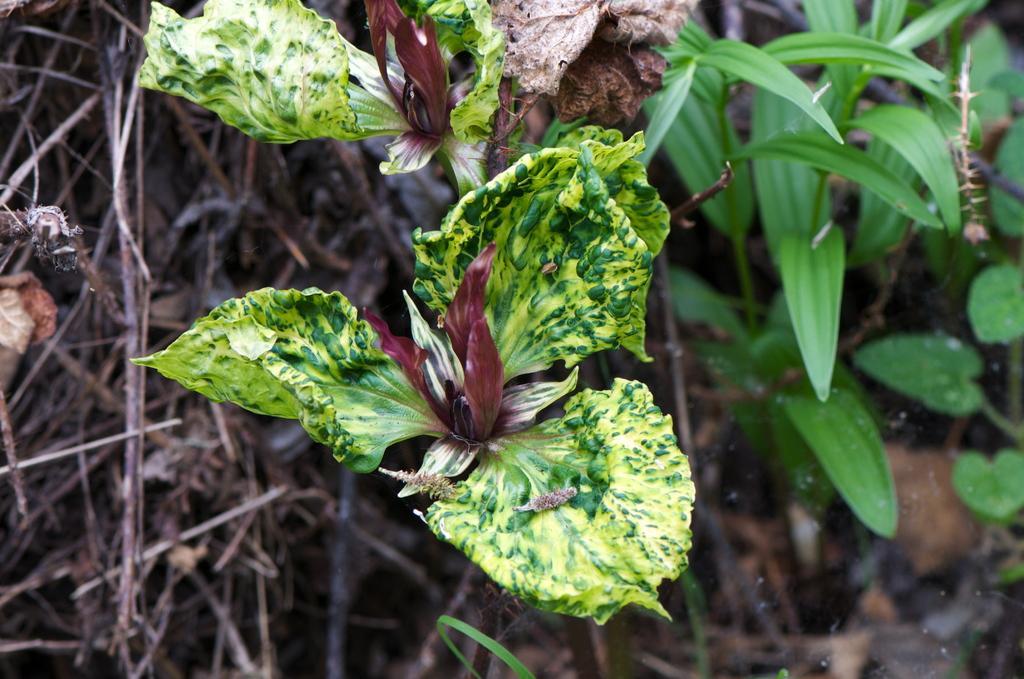In one or two sentences, can you explain what this image depicts? In the picture we can see some dried twigs and leaves and besides, we can see some plants and leaves which are green in color. 